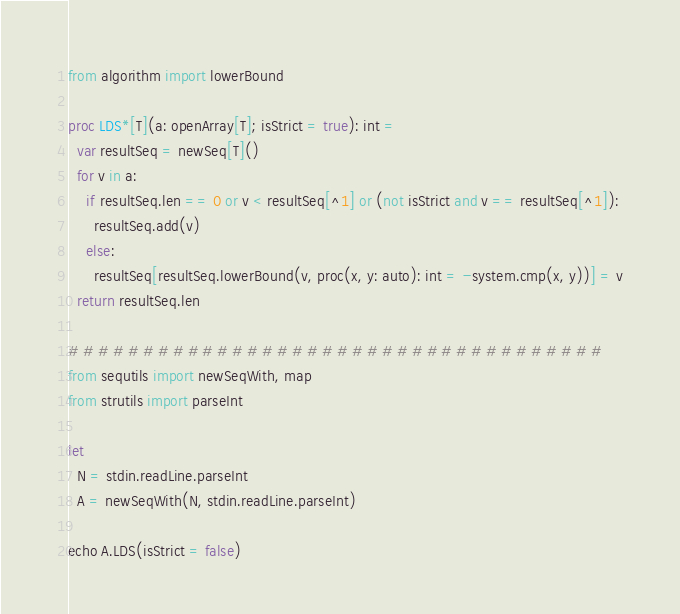Convert code to text. <code><loc_0><loc_0><loc_500><loc_500><_Nim_>from algorithm import lowerBound

proc LDS*[T](a: openArray[T]; isStrict = true): int =
  var resultSeq = newSeq[T]()
  for v in a:
    if resultSeq.len == 0 or v < resultSeq[^1] or (not isStrict and v == resultSeq[^1]):
      resultSeq.add(v)
    else:
      resultSeq[resultSeq.lowerBound(v, proc(x, y: auto): int = -system.cmp(x, y))] = v
  return resultSeq.len

# # # # # # # # # # # # # # # # # # # # # # # # # # # # # # # # # # # #
from sequtils import newSeqWith, map
from strutils import parseInt

let
  N = stdin.readLine.parseInt
  A = newSeqWith(N, stdin.readLine.parseInt)

echo A.LDS(isStrict = false)
</code> 